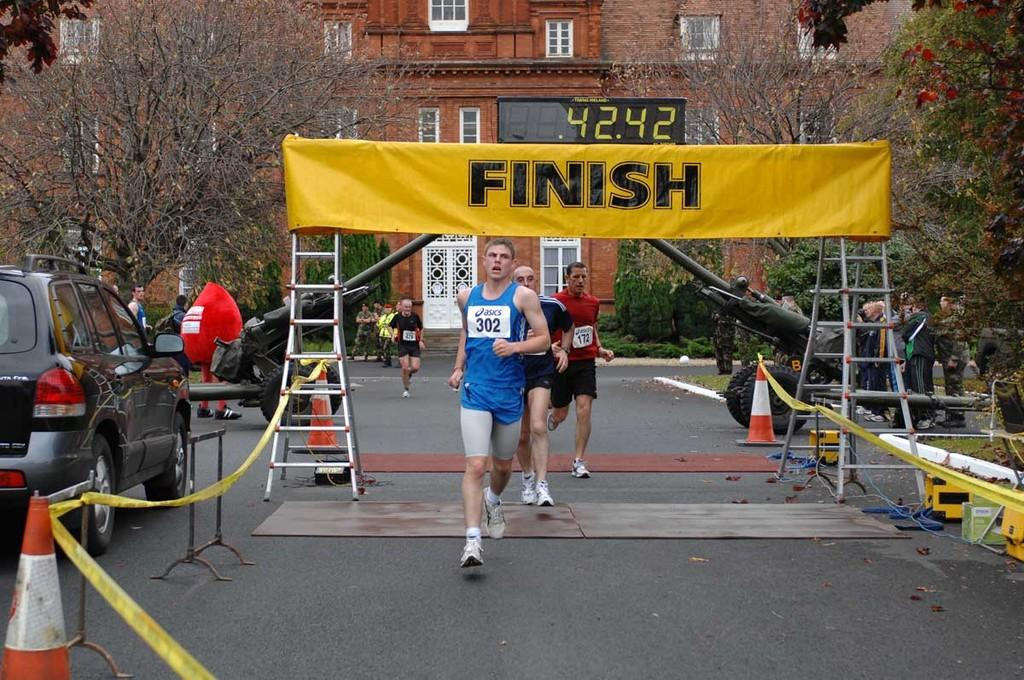<image>
Provide a brief description of the given image. a finish sign that is above the ground 